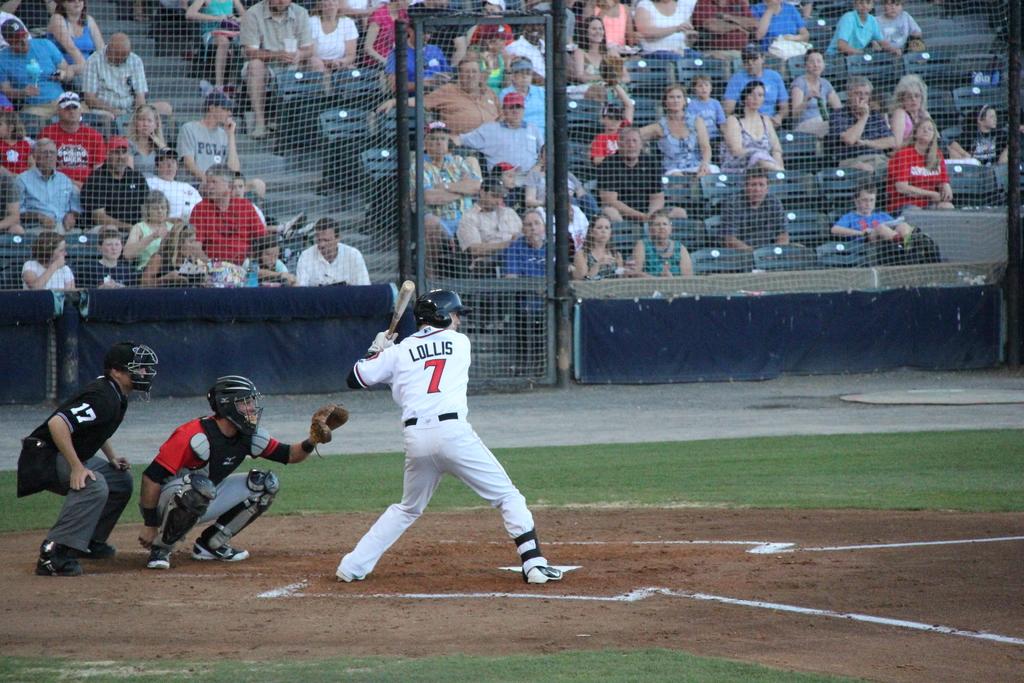What is the name of the player that is batting?
Give a very brief answer. Lollis. 